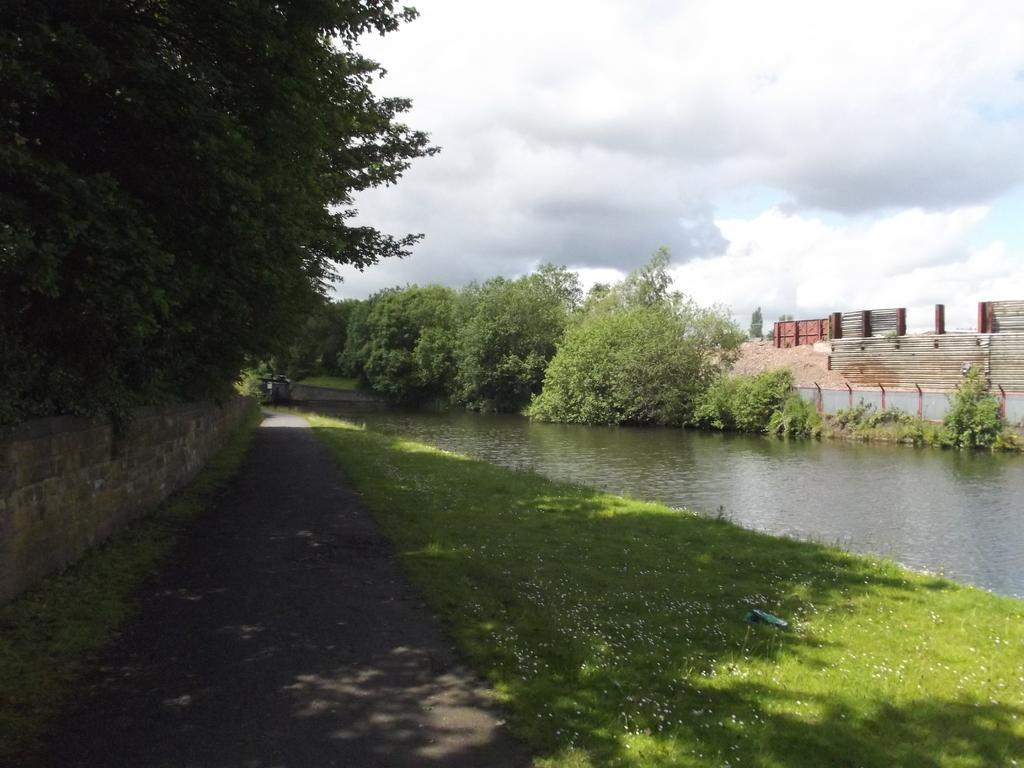Please provide a concise description of this image. In this picture I can see grass, there is water, there are trees, there is fence, and in the background there is the sky. 